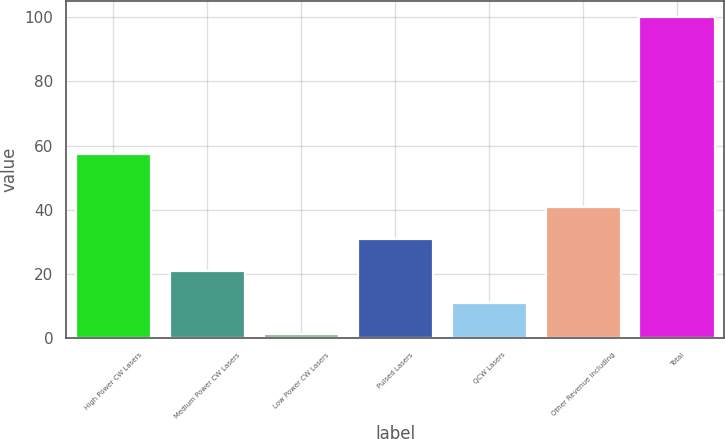Convert chart to OTSL. <chart><loc_0><loc_0><loc_500><loc_500><bar_chart><fcel>High Power CW Lasers<fcel>Medium Power CW Lasers<fcel>Low Power CW Lasers<fcel>Pulsed Lasers<fcel>QCW Lasers<fcel>Other Revenue including<fcel>Total<nl><fcel>57.5<fcel>21.04<fcel>1.3<fcel>30.91<fcel>11.17<fcel>40.78<fcel>100<nl></chart> 